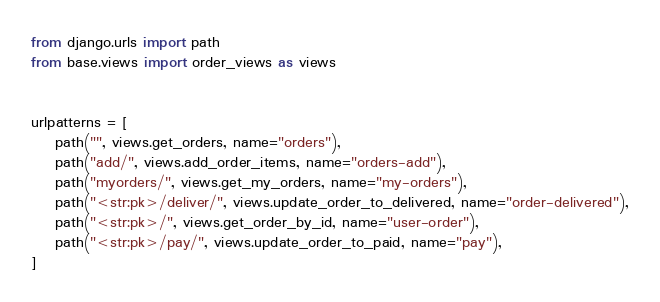<code> <loc_0><loc_0><loc_500><loc_500><_Python_>from django.urls import path
from base.views import order_views as views


urlpatterns = [
    path("", views.get_orders, name="orders"),
    path("add/", views.add_order_items, name="orders-add"),
    path("myorders/", views.get_my_orders, name="my-orders"),
    path("<str:pk>/deliver/", views.update_order_to_delivered, name="order-delivered"),
    path("<str:pk>/", views.get_order_by_id, name="user-order"),
    path("<str:pk>/pay/", views.update_order_to_paid, name="pay"),
]
</code> 